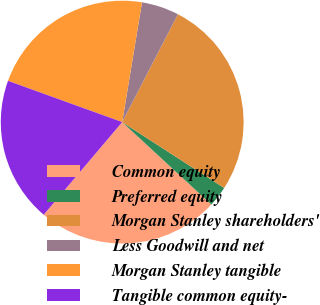Convert chart. <chart><loc_0><loc_0><loc_500><loc_500><pie_chart><fcel>Common equity<fcel>Preferred equity<fcel>Morgan Stanley shareholders'<fcel>Less Goodwill and net<fcel>Morgan Stanley tangible<fcel>Tangible common equity-<nl><fcel>24.31%<fcel>2.75%<fcel>26.54%<fcel>4.98%<fcel>22.09%<fcel>19.33%<nl></chart> 